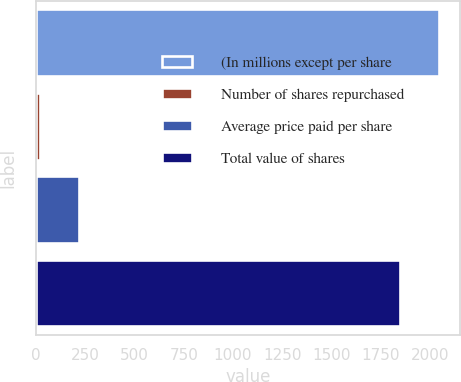<chart> <loc_0><loc_0><loc_500><loc_500><bar_chart><fcel>(In millions except per share<fcel>Number of shares repurchased<fcel>Average price paid per share<fcel>Total value of shares<nl><fcel>2049.2<fcel>20<fcel>219.2<fcel>1850<nl></chart> 